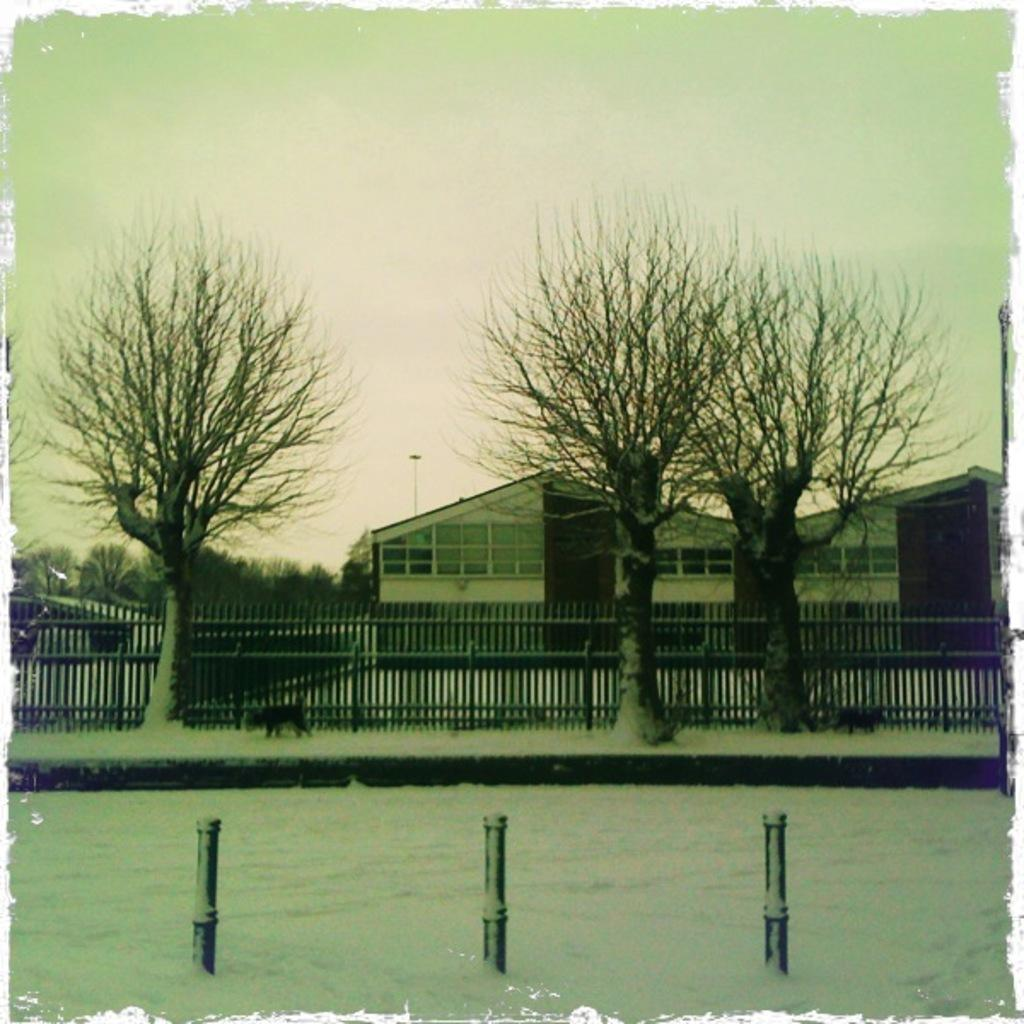How many poles can be seen in the image? There are three poles in the image. What other structures are visible in the image? There is a railing visible in the image. What type of natural environment is depicted in the image? There are many trees in the image, suggesting a forest or wooded area. What can be seen in the background of the image? There are houses and the sky visible in the background of the image. What type of celery is being used to repair the wrench in the image? There is no celery or wrench present in the image, so this question cannot be answered. 